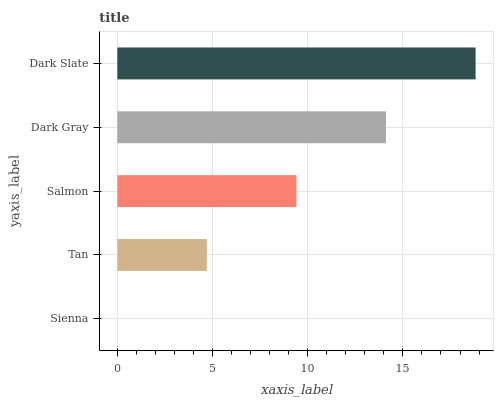Is Sienna the minimum?
Answer yes or no. Yes. Is Dark Slate the maximum?
Answer yes or no. Yes. Is Tan the minimum?
Answer yes or no. No. Is Tan the maximum?
Answer yes or no. No. Is Tan greater than Sienna?
Answer yes or no. Yes. Is Sienna less than Tan?
Answer yes or no. Yes. Is Sienna greater than Tan?
Answer yes or no. No. Is Tan less than Sienna?
Answer yes or no. No. Is Salmon the high median?
Answer yes or no. Yes. Is Salmon the low median?
Answer yes or no. Yes. Is Dark Gray the high median?
Answer yes or no. No. Is Tan the low median?
Answer yes or no. No. 